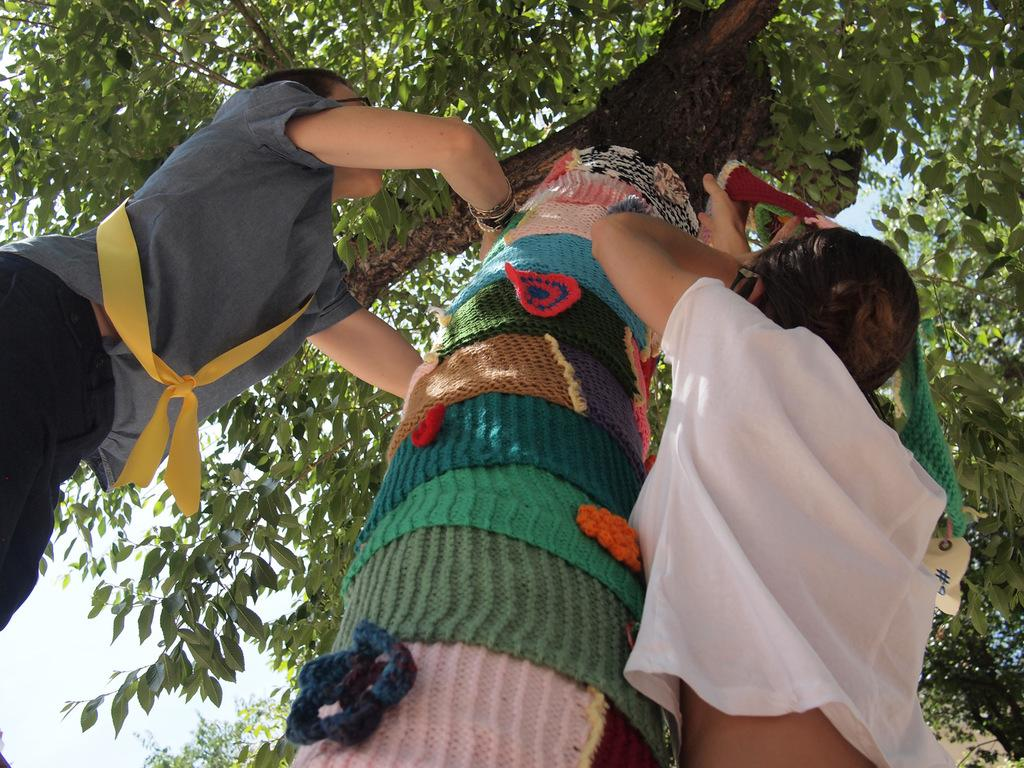How many people are in the image? There are two people in the image. What is one person doing in the image? One person is holding something. What can be seen in the background of the image? The sky is visible in the image. What is an unusual feature in the image? There are clothes hanging on a tree in the image. What type of quill is being used by one of the people in the image? There is no quill present in the image; it is not a tool used by either person. 